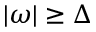<formula> <loc_0><loc_0><loc_500><loc_500>| \omega | \geq \Delta</formula> 